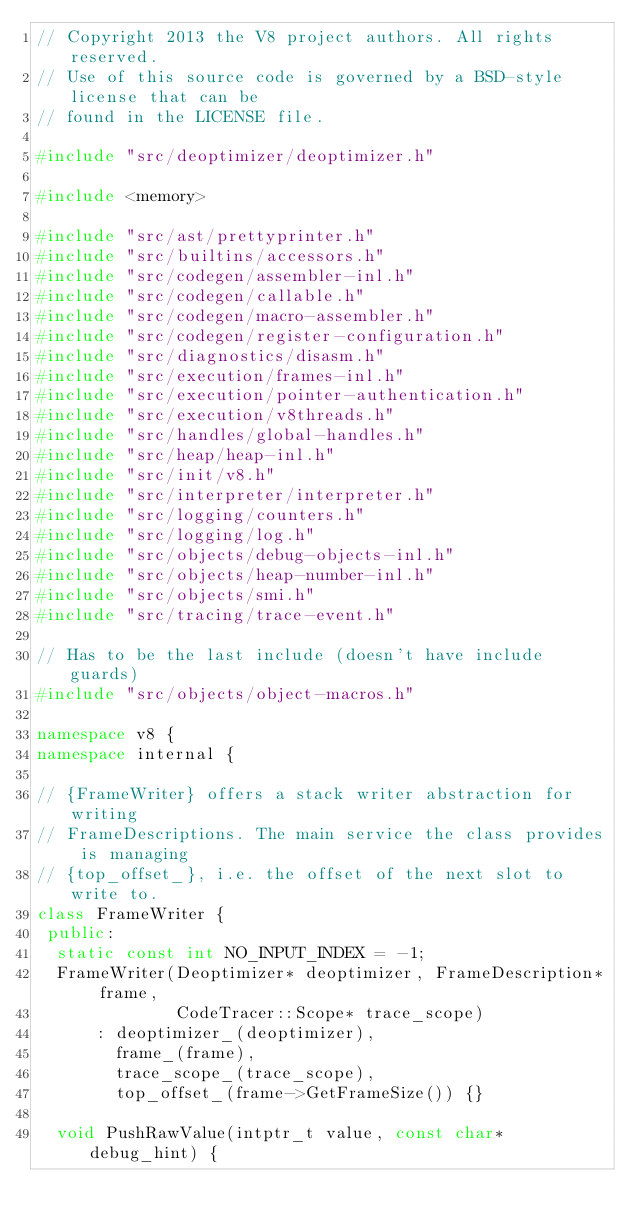<code> <loc_0><loc_0><loc_500><loc_500><_C++_>// Copyright 2013 the V8 project authors. All rights reserved.
// Use of this source code is governed by a BSD-style license that can be
// found in the LICENSE file.

#include "src/deoptimizer/deoptimizer.h"

#include <memory>

#include "src/ast/prettyprinter.h"
#include "src/builtins/accessors.h"
#include "src/codegen/assembler-inl.h"
#include "src/codegen/callable.h"
#include "src/codegen/macro-assembler.h"
#include "src/codegen/register-configuration.h"
#include "src/diagnostics/disasm.h"
#include "src/execution/frames-inl.h"
#include "src/execution/pointer-authentication.h"
#include "src/execution/v8threads.h"
#include "src/handles/global-handles.h"
#include "src/heap/heap-inl.h"
#include "src/init/v8.h"
#include "src/interpreter/interpreter.h"
#include "src/logging/counters.h"
#include "src/logging/log.h"
#include "src/objects/debug-objects-inl.h"
#include "src/objects/heap-number-inl.h"
#include "src/objects/smi.h"
#include "src/tracing/trace-event.h"

// Has to be the last include (doesn't have include guards)
#include "src/objects/object-macros.h"

namespace v8 {
namespace internal {

// {FrameWriter} offers a stack writer abstraction for writing
// FrameDescriptions. The main service the class provides is managing
// {top_offset_}, i.e. the offset of the next slot to write to.
class FrameWriter {
 public:
  static const int NO_INPUT_INDEX = -1;
  FrameWriter(Deoptimizer* deoptimizer, FrameDescription* frame,
              CodeTracer::Scope* trace_scope)
      : deoptimizer_(deoptimizer),
        frame_(frame),
        trace_scope_(trace_scope),
        top_offset_(frame->GetFrameSize()) {}

  void PushRawValue(intptr_t value, const char* debug_hint) {</code> 